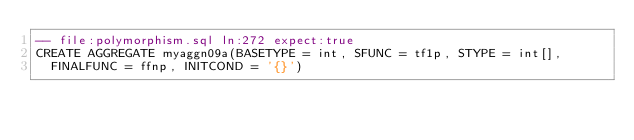<code> <loc_0><loc_0><loc_500><loc_500><_SQL_>-- file:polymorphism.sql ln:272 expect:true
CREATE AGGREGATE myaggn09a(BASETYPE = int, SFUNC = tf1p, STYPE = int[],
  FINALFUNC = ffnp, INITCOND = '{}')
</code> 